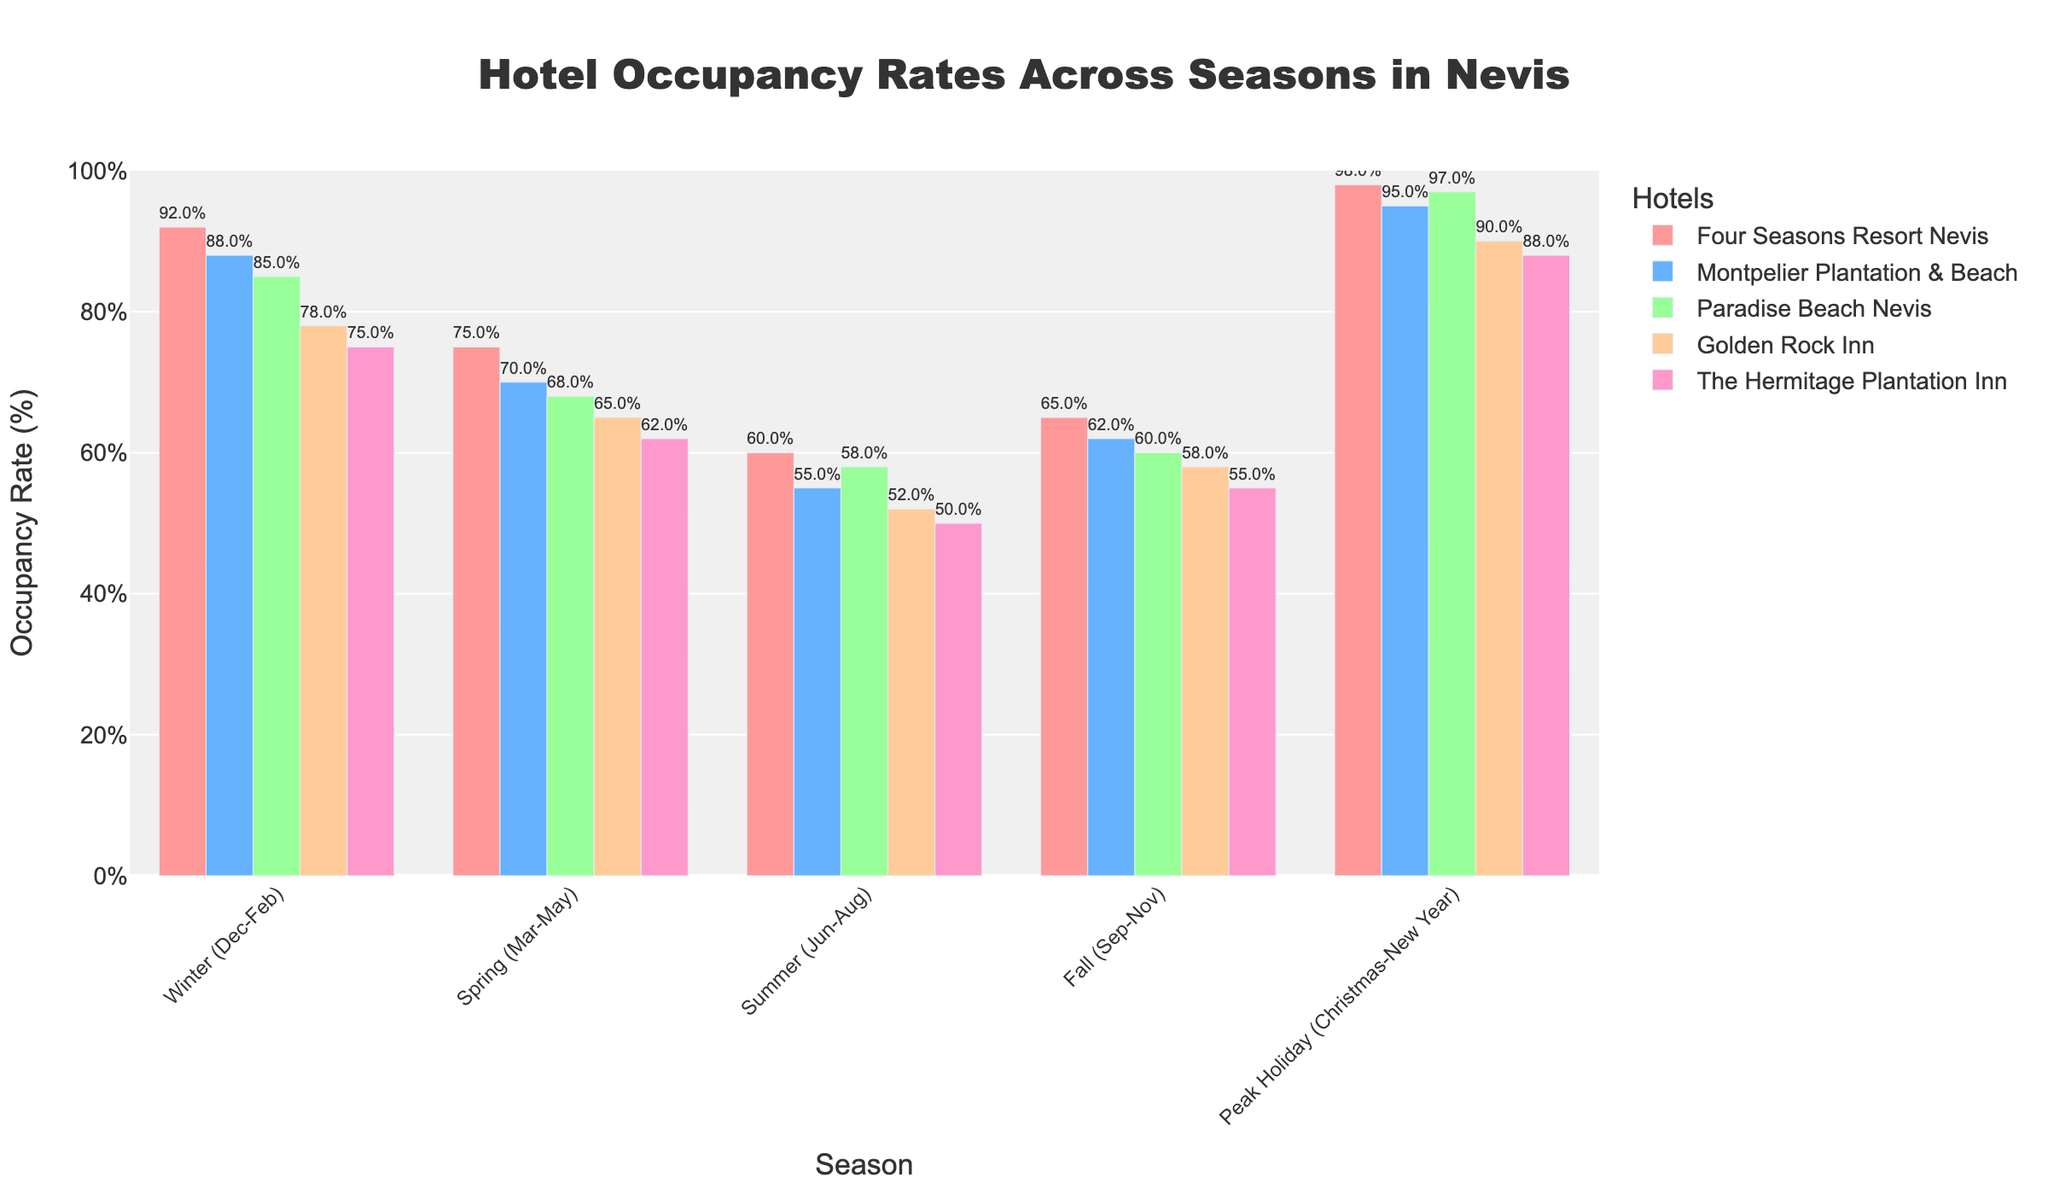What season has the highest hotel occupancy rate at Four Seasons Resort Nevis? The figure shows that the highest occupancy rate for Four Seasons Resort Nevis occurs during the Peak Holiday (Christmas-New Year) season. This is depicted by the tallest bar for Four Seasons Resort Nevis in the chart.
Answer: Peak Holiday (Christmas-New Year) Which hotel has the lowest occupancy rate during the Summer season? To find the hotel with the lowest occupancy rate during the Summer season, we look for the shortest bar in the Summer (Jun-Aug) section of the chart. The Hermitage Plantation Inn has the shortest bar.
Answer: The Hermitage Plantation Inn What is the average occupancy rate for Paradise Beach Nevis across all seasons depicted? First, list the occupancy rates for Paradise Beach Nevis in all seasons: 85, 68, 58, 60, 97. Then, calculate the average by summing these values (85 + 68 + 58 + 60 + 97 = 368) and dividing by the number of seasons (5). The average is 368 / 5 = 73.6.
Answer: 73.6% How does the occupancy rate of Montpelier Plantation & Beach in Winter compare to its rate in Summer? The occupancy rate for Montpelier Plantation & Beach in Winter is 88%, while in Summer, it is 55%. The comparison shows that the Winter rate is higher than the Summer rate.
Answer: Winter is higher What is the difference between the highest and lowest occupancy rates for Golden Rock Inn? First, identify the highest (90% during Peak Holiday) and lowest (52% during Summer) occupancy rates for Golden Rock Inn. Then, calculate the difference: 90 - 52 = 38.
Answer: 38% Which season has the most consistent occupancy rates across all hotels? To determine the most consistent season, look for the season where the occupancy rates of all hotels are closest in value. The Fall season (Sep-Nov) has rates between 55% and 65% for all hotels, which appears the most consistent.
Answer: Fall How much higher is the occupancy rate at Paradise Beach Nevis during Peak Holiday compared to Spring? The occupancy rate at Paradise Beach Nevis during Peak Holiday is 97%, and during Spring, it is 68%. The difference is calculated as 97 - 68 = 29.
Answer: 29% What is the overall trend in occupancy rates from Winter to Summer at The Hermitage Plantation Inn? Observing the figure, the occupancy rate of The Hermitage Plantation Inn goes from 75% in Winter, decreases to 62% in Spring, and then further decreases to 50% in Summer, showing a downward trend.
Answer: Downward trend Which hotel has the highest peak occupancy rate, and in which season does it occur? The highest peak occupancy rate is observed at Four Seasons Resort Nevis with 98% during the Peak Holiday (Christmas-New Year) season.
Answer: Four Seasons Resort Nevis in Peak Holiday What is the combined occupancy rate of all hotels during Spring? Add the Spring occupancy rates for all hotels: 75 (Four Seasons Resort Nevis) + 70 (Montpelier Plantation & Beach) + 68 (Paradise Beach Nevis) + 65 (Golden Rock Inn) + 62 (The Hermitage Plantation Inn) = 340.
Answer: 340% 